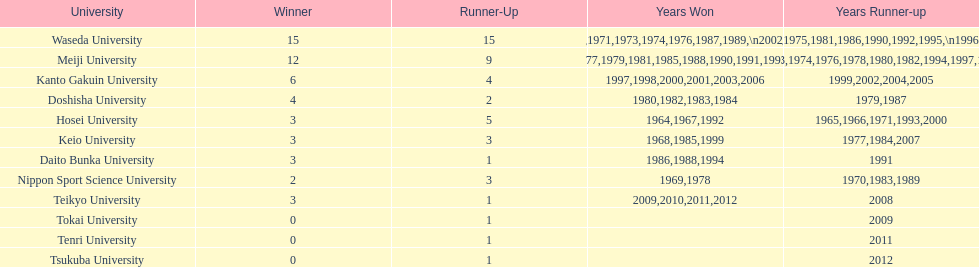Which universities had a number of wins higher than 12? Waseda University. Give me the full table as a dictionary. {'header': ['University', 'Winner', 'Runner-Up', 'Years Won', 'Years Runner-up'], 'rows': [['Waseda University', '15', '15', '1965,1966,1968,1970,1971,1973,1974,1976,1987,1989,\\n2002,2004,2005,2007,2008', '1964,1967,1969,1972,1975,1981,1986,1990,1992,1995,\\n1996,2001,2003,2006,2010'], ['Meiji University', '12', '9', '1972,1975,1977,1979,1981,1985,1988,1990,1991,1993,\\n1995,1996', '1973,1974,1976,1978,1980,1982,1994,1997,1998'], ['Kanto Gakuin University', '6', '4', '1997,1998,2000,2001,2003,2006', '1999,2002,2004,2005'], ['Doshisha University', '4', '2', '1980,1982,1983,1984', '1979,1987'], ['Hosei University', '3', '5', '1964,1967,1992', '1965,1966,1971,1993,2000'], ['Keio University', '3', '3', '1968,1985,1999', '1977,1984,2007'], ['Daito Bunka University', '3', '1', '1986,1988,1994', '1991'], ['Nippon Sport Science University', '2', '3', '1969,1978', '1970,1983,1989'], ['Teikyo University', '3', '1', '2009,2010,2011,2012', '2008'], ['Tokai University', '0', '1', '', '2009'], ['Tenri University', '0', '1', '', '2011'], ['Tsukuba University', '0', '1', '', '2012']]} 